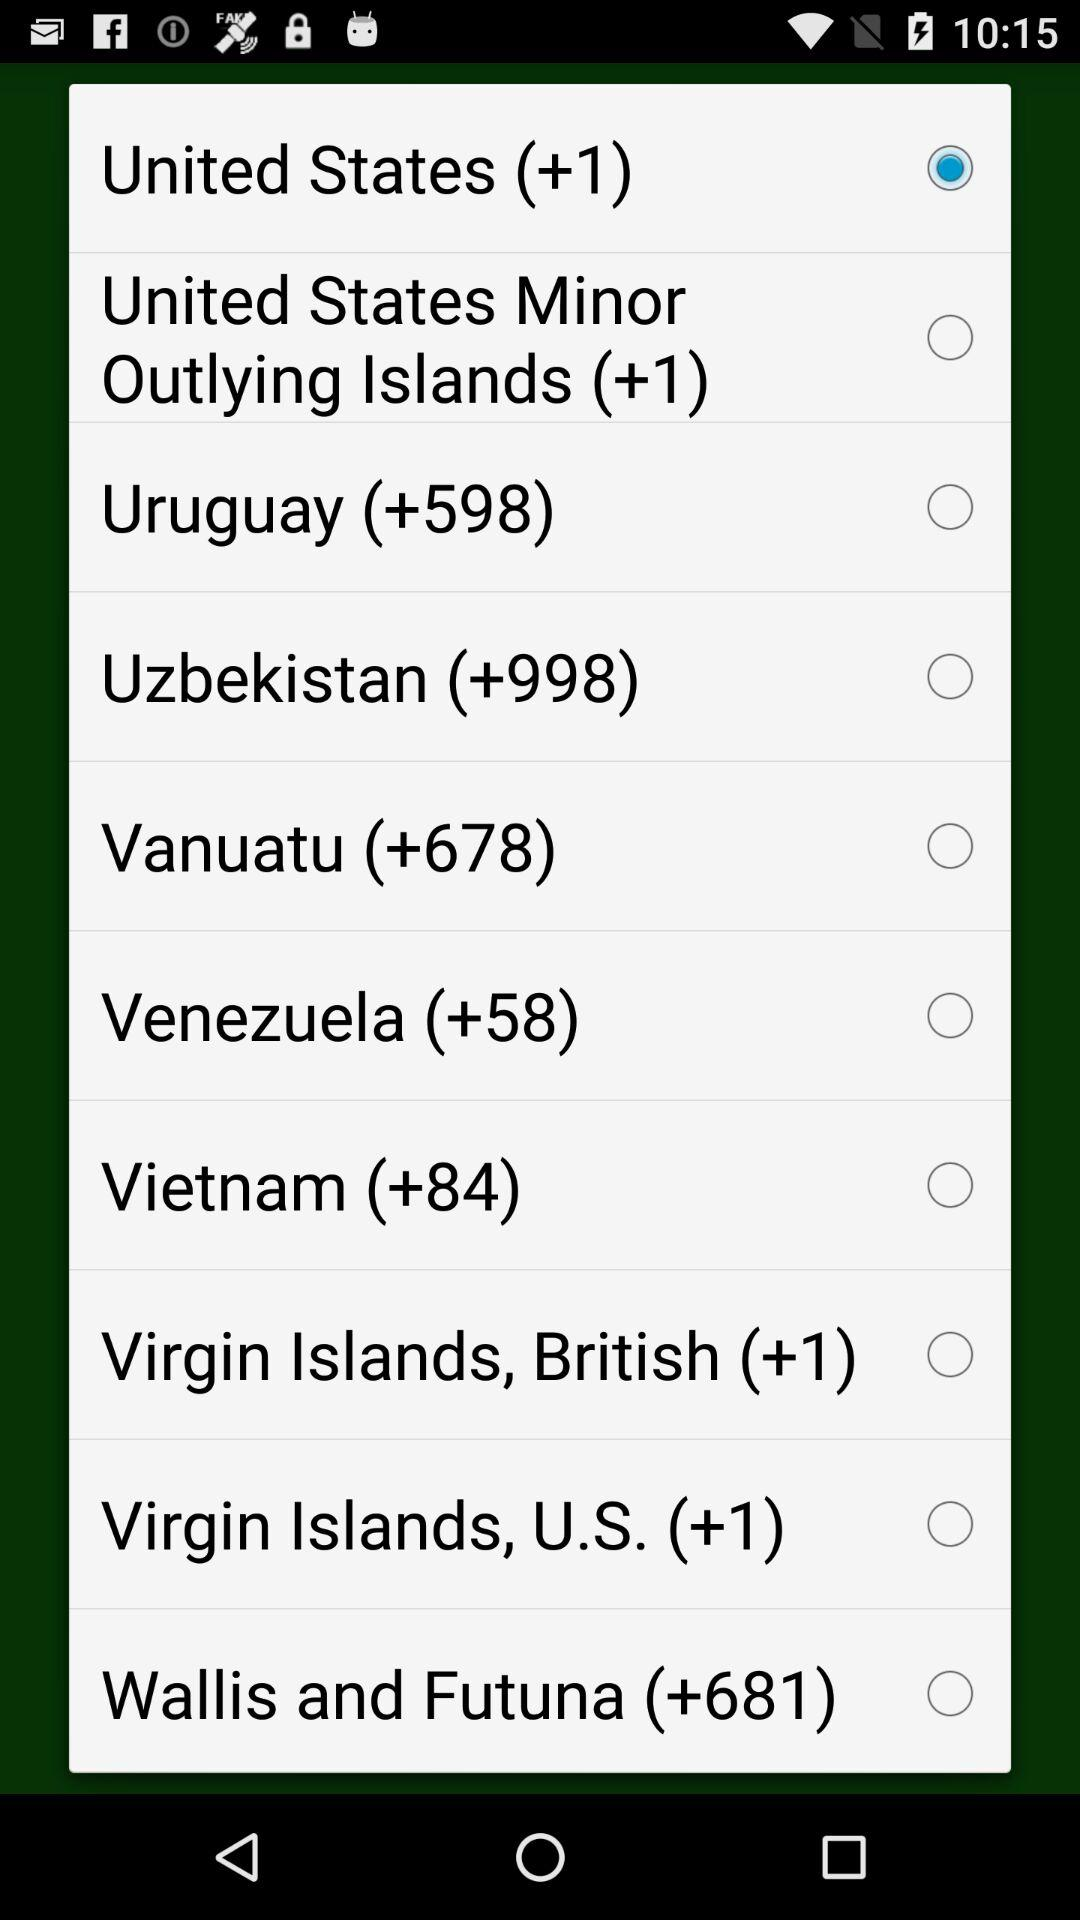What is the code of the United States? The code of the United States is +1. 